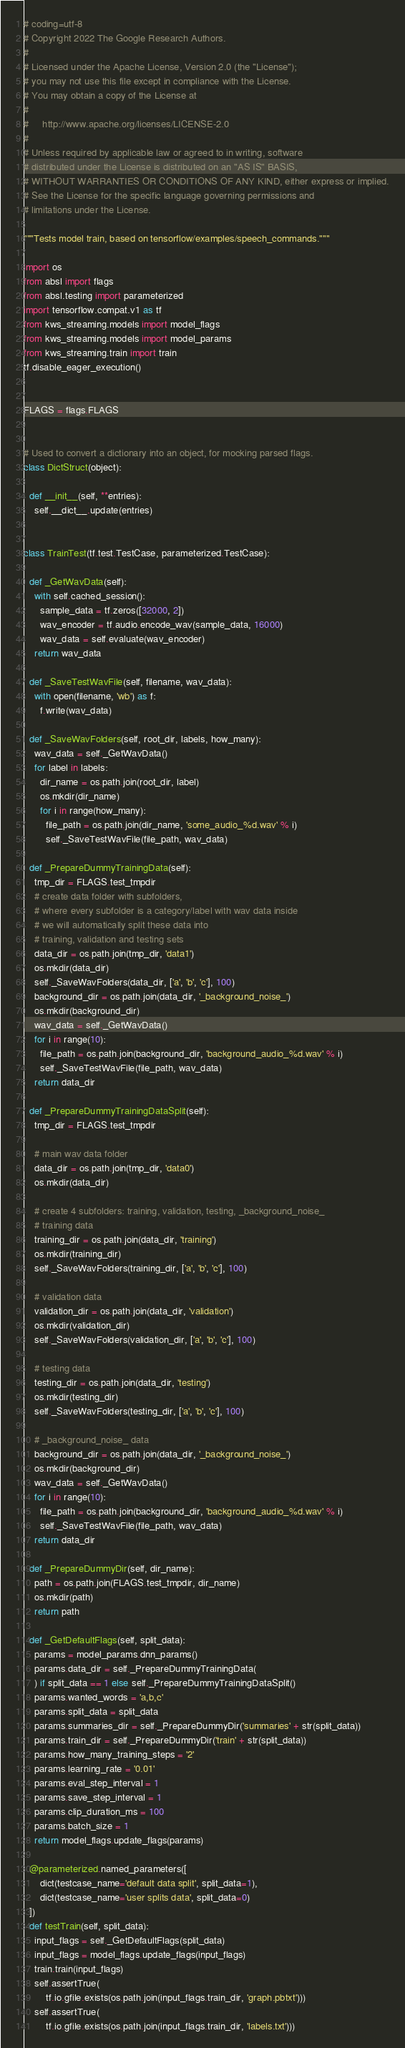<code> <loc_0><loc_0><loc_500><loc_500><_Python_># coding=utf-8
# Copyright 2022 The Google Research Authors.
#
# Licensed under the Apache License, Version 2.0 (the "License");
# you may not use this file except in compliance with the License.
# You may obtain a copy of the License at
#
#     http://www.apache.org/licenses/LICENSE-2.0
#
# Unless required by applicable law or agreed to in writing, software
# distributed under the License is distributed on an "AS IS" BASIS,
# WITHOUT WARRANTIES OR CONDITIONS OF ANY KIND, either express or implied.
# See the License for the specific language governing permissions and
# limitations under the License.

"""Tests model train, based on tensorflow/examples/speech_commands."""

import os
from absl import flags
from absl.testing import parameterized
import tensorflow.compat.v1 as tf
from kws_streaming.models import model_flags
from kws_streaming.models import model_params
from kws_streaming.train import train
tf.disable_eager_execution()


FLAGS = flags.FLAGS


# Used to convert a dictionary into an object, for mocking parsed flags.
class DictStruct(object):

  def __init__(self, **entries):
    self.__dict__.update(entries)


class TrainTest(tf.test.TestCase, parameterized.TestCase):

  def _GetWavData(self):
    with self.cached_session():
      sample_data = tf.zeros([32000, 2])
      wav_encoder = tf.audio.encode_wav(sample_data, 16000)
      wav_data = self.evaluate(wav_encoder)
    return wav_data

  def _SaveTestWavFile(self, filename, wav_data):
    with open(filename, 'wb') as f:
      f.write(wav_data)

  def _SaveWavFolders(self, root_dir, labels, how_many):
    wav_data = self._GetWavData()
    for label in labels:
      dir_name = os.path.join(root_dir, label)
      os.mkdir(dir_name)
      for i in range(how_many):
        file_path = os.path.join(dir_name, 'some_audio_%d.wav' % i)
        self._SaveTestWavFile(file_path, wav_data)

  def _PrepareDummyTrainingData(self):
    tmp_dir = FLAGS.test_tmpdir
    # create data folder with subfolders,
    # where every subfolder is a category/label with wav data inside
    # we will automatically split these data into
    # training, validation and testing sets
    data_dir = os.path.join(tmp_dir, 'data1')
    os.mkdir(data_dir)
    self._SaveWavFolders(data_dir, ['a', 'b', 'c'], 100)
    background_dir = os.path.join(data_dir, '_background_noise_')
    os.mkdir(background_dir)
    wav_data = self._GetWavData()
    for i in range(10):
      file_path = os.path.join(background_dir, 'background_audio_%d.wav' % i)
      self._SaveTestWavFile(file_path, wav_data)
    return data_dir

  def _PrepareDummyTrainingDataSplit(self):
    tmp_dir = FLAGS.test_tmpdir

    # main wav data folder
    data_dir = os.path.join(tmp_dir, 'data0')
    os.mkdir(data_dir)

    # create 4 subfolders: training, validation, testing, _background_noise_
    # training data
    training_dir = os.path.join(data_dir, 'training')
    os.mkdir(training_dir)
    self._SaveWavFolders(training_dir, ['a', 'b', 'c'], 100)

    # validation data
    validation_dir = os.path.join(data_dir, 'validation')
    os.mkdir(validation_dir)
    self._SaveWavFolders(validation_dir, ['a', 'b', 'c'], 100)

    # testing data
    testing_dir = os.path.join(data_dir, 'testing')
    os.mkdir(testing_dir)
    self._SaveWavFolders(testing_dir, ['a', 'b', 'c'], 100)

    # _background_noise_ data
    background_dir = os.path.join(data_dir, '_background_noise_')
    os.mkdir(background_dir)
    wav_data = self._GetWavData()
    for i in range(10):
      file_path = os.path.join(background_dir, 'background_audio_%d.wav' % i)
      self._SaveTestWavFile(file_path, wav_data)
    return data_dir

  def _PrepareDummyDir(self, dir_name):
    path = os.path.join(FLAGS.test_tmpdir, dir_name)
    os.mkdir(path)
    return path

  def _GetDefaultFlags(self, split_data):
    params = model_params.dnn_params()
    params.data_dir = self._PrepareDummyTrainingData(
    ) if split_data == 1 else self._PrepareDummyTrainingDataSplit()
    params.wanted_words = 'a,b,c'
    params.split_data = split_data
    params.summaries_dir = self._PrepareDummyDir('summaries' + str(split_data))
    params.train_dir = self._PrepareDummyDir('train' + str(split_data))
    params.how_many_training_steps = '2'
    params.learning_rate = '0.01'
    params.eval_step_interval = 1
    params.save_step_interval = 1
    params.clip_duration_ms = 100
    params.batch_size = 1
    return model_flags.update_flags(params)

  @parameterized.named_parameters([
      dict(testcase_name='default data split', split_data=1),
      dict(testcase_name='user splits data', split_data=0)
  ])
  def testTrain(self, split_data):
    input_flags = self._GetDefaultFlags(split_data)
    input_flags = model_flags.update_flags(input_flags)
    train.train(input_flags)
    self.assertTrue(
        tf.io.gfile.exists(os.path.join(input_flags.train_dir, 'graph.pbtxt')))
    self.assertTrue(
        tf.io.gfile.exists(os.path.join(input_flags.train_dir, 'labels.txt')))</code> 